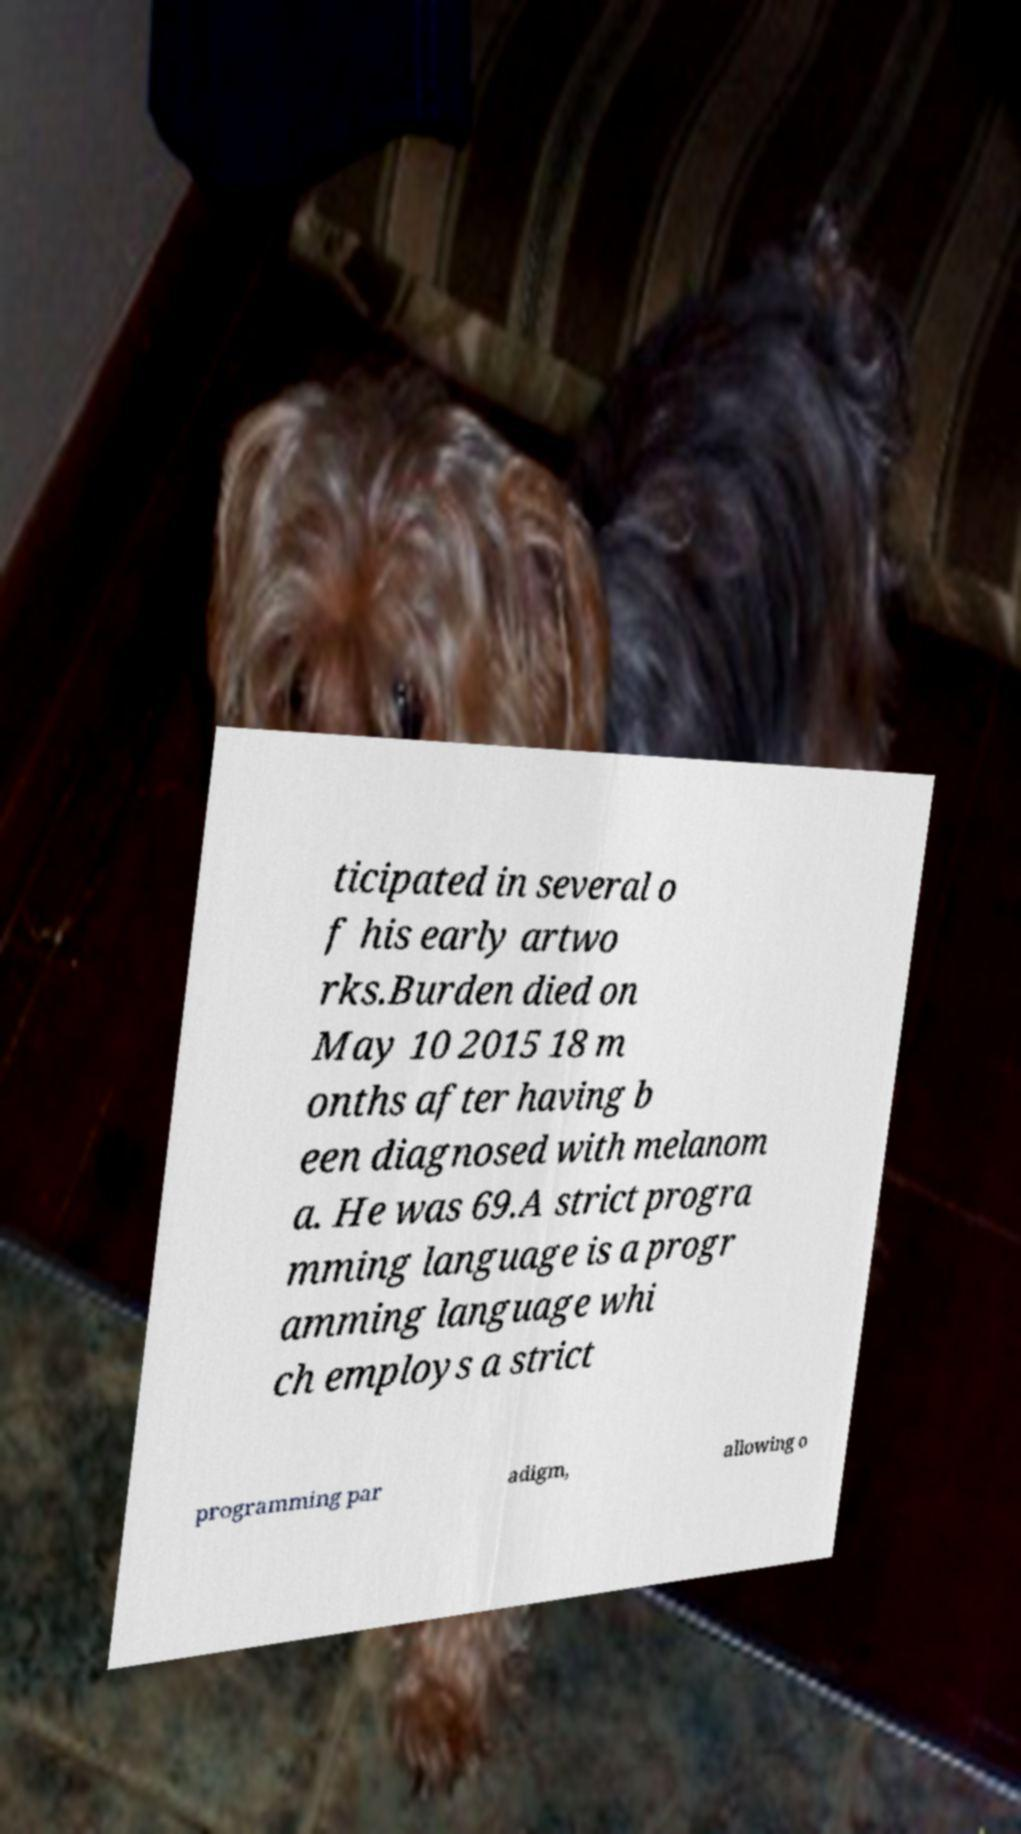Please identify and transcribe the text found in this image. ticipated in several o f his early artwo rks.Burden died on May 10 2015 18 m onths after having b een diagnosed with melanom a. He was 69.A strict progra mming language is a progr amming language whi ch employs a strict programming par adigm, allowing o 